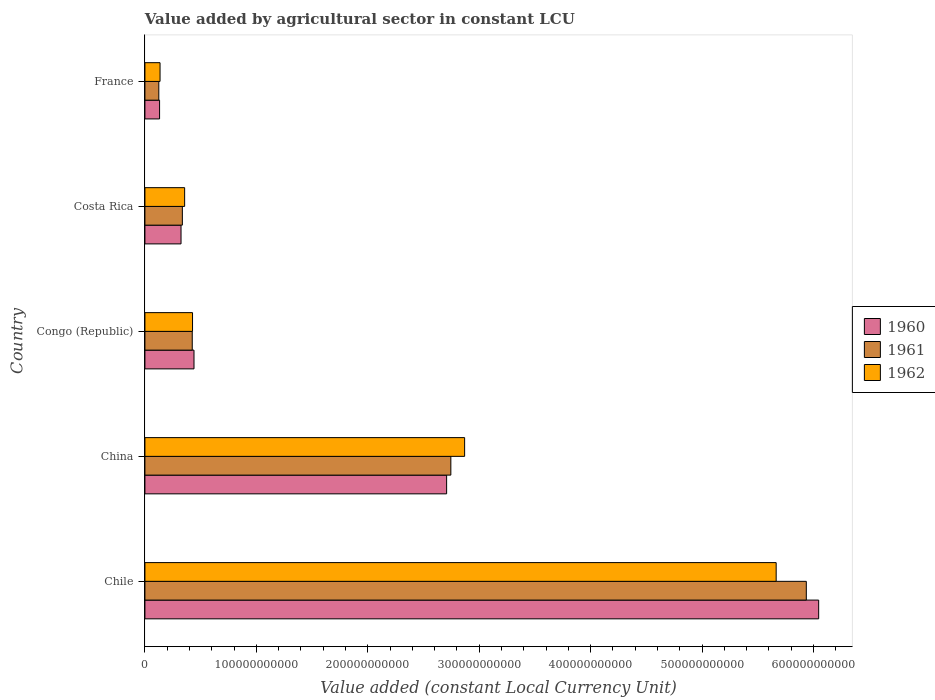How many different coloured bars are there?
Provide a succinct answer. 3. How many groups of bars are there?
Provide a short and direct response. 5. Are the number of bars on each tick of the Y-axis equal?
Provide a short and direct response. Yes. How many bars are there on the 3rd tick from the bottom?
Your response must be concise. 3. In how many cases, is the number of bars for a given country not equal to the number of legend labels?
Ensure brevity in your answer.  0. What is the value added by agricultural sector in 1960 in Chile?
Ensure brevity in your answer.  6.05e+11. Across all countries, what is the maximum value added by agricultural sector in 1960?
Keep it short and to the point. 6.05e+11. Across all countries, what is the minimum value added by agricultural sector in 1962?
Offer a very short reply. 1.36e+1. In which country was the value added by agricultural sector in 1962 maximum?
Your answer should be very brief. Chile. What is the total value added by agricultural sector in 1960 in the graph?
Your answer should be compact. 9.65e+11. What is the difference between the value added by agricultural sector in 1960 in China and that in Congo (Republic)?
Make the answer very short. 2.27e+11. What is the difference between the value added by agricultural sector in 1960 in China and the value added by agricultural sector in 1961 in France?
Keep it short and to the point. 2.58e+11. What is the average value added by agricultural sector in 1960 per country?
Your answer should be very brief. 1.93e+11. What is the difference between the value added by agricultural sector in 1962 and value added by agricultural sector in 1960 in Costa Rica?
Provide a short and direct response. 3.25e+09. In how many countries, is the value added by agricultural sector in 1960 greater than 240000000000 LCU?
Make the answer very short. 2. What is the ratio of the value added by agricultural sector in 1960 in China to that in Costa Rica?
Provide a short and direct response. 8.36. Is the value added by agricultural sector in 1961 in Chile less than that in Congo (Republic)?
Provide a succinct answer. No. Is the difference between the value added by agricultural sector in 1962 in Congo (Republic) and Costa Rica greater than the difference between the value added by agricultural sector in 1960 in Congo (Republic) and Costa Rica?
Provide a succinct answer. No. What is the difference between the highest and the second highest value added by agricultural sector in 1962?
Make the answer very short. 2.80e+11. What is the difference between the highest and the lowest value added by agricultural sector in 1962?
Offer a very short reply. 5.53e+11. What does the 2nd bar from the bottom in France represents?
Make the answer very short. 1961. What is the difference between two consecutive major ticks on the X-axis?
Offer a terse response. 1.00e+11. Are the values on the major ticks of X-axis written in scientific E-notation?
Your answer should be compact. No. Does the graph contain any zero values?
Give a very brief answer. No. Where does the legend appear in the graph?
Keep it short and to the point. Center right. How many legend labels are there?
Provide a succinct answer. 3. How are the legend labels stacked?
Provide a succinct answer. Vertical. What is the title of the graph?
Your answer should be very brief. Value added by agricultural sector in constant LCU. Does "1981" appear as one of the legend labels in the graph?
Your answer should be compact. No. What is the label or title of the X-axis?
Give a very brief answer. Value added (constant Local Currency Unit). What is the label or title of the Y-axis?
Give a very brief answer. Country. What is the Value added (constant Local Currency Unit) of 1960 in Chile?
Your answer should be compact. 6.05e+11. What is the Value added (constant Local Currency Unit) in 1961 in Chile?
Your answer should be very brief. 5.94e+11. What is the Value added (constant Local Currency Unit) in 1962 in Chile?
Your answer should be compact. 5.67e+11. What is the Value added (constant Local Currency Unit) of 1960 in China?
Provide a short and direct response. 2.71e+11. What is the Value added (constant Local Currency Unit) of 1961 in China?
Your answer should be compact. 2.75e+11. What is the Value added (constant Local Currency Unit) in 1962 in China?
Your answer should be very brief. 2.87e+11. What is the Value added (constant Local Currency Unit) in 1960 in Congo (Republic)?
Provide a short and direct response. 4.41e+1. What is the Value added (constant Local Currency Unit) in 1961 in Congo (Republic)?
Keep it short and to the point. 4.25e+1. What is the Value added (constant Local Currency Unit) of 1962 in Congo (Republic)?
Provide a succinct answer. 4.27e+1. What is the Value added (constant Local Currency Unit) of 1960 in Costa Rica?
Offer a terse response. 3.24e+1. What is the Value added (constant Local Currency Unit) in 1961 in Costa Rica?
Provide a short and direct response. 3.36e+1. What is the Value added (constant Local Currency Unit) in 1962 in Costa Rica?
Ensure brevity in your answer.  3.57e+1. What is the Value added (constant Local Currency Unit) in 1960 in France?
Make the answer very short. 1.32e+1. What is the Value added (constant Local Currency Unit) of 1961 in France?
Provide a succinct answer. 1.25e+1. What is the Value added (constant Local Currency Unit) of 1962 in France?
Provide a succinct answer. 1.36e+1. Across all countries, what is the maximum Value added (constant Local Currency Unit) of 1960?
Make the answer very short. 6.05e+11. Across all countries, what is the maximum Value added (constant Local Currency Unit) of 1961?
Your answer should be very brief. 5.94e+11. Across all countries, what is the maximum Value added (constant Local Currency Unit) of 1962?
Your response must be concise. 5.67e+11. Across all countries, what is the minimum Value added (constant Local Currency Unit) of 1960?
Your response must be concise. 1.32e+1. Across all countries, what is the minimum Value added (constant Local Currency Unit) in 1961?
Provide a succinct answer. 1.25e+1. Across all countries, what is the minimum Value added (constant Local Currency Unit) in 1962?
Your answer should be very brief. 1.36e+1. What is the total Value added (constant Local Currency Unit) of 1960 in the graph?
Provide a succinct answer. 9.65e+11. What is the total Value added (constant Local Currency Unit) in 1961 in the graph?
Ensure brevity in your answer.  9.57e+11. What is the total Value added (constant Local Currency Unit) of 1962 in the graph?
Provide a short and direct response. 9.45e+11. What is the difference between the Value added (constant Local Currency Unit) in 1960 in Chile and that in China?
Your answer should be compact. 3.34e+11. What is the difference between the Value added (constant Local Currency Unit) in 1961 in Chile and that in China?
Ensure brevity in your answer.  3.19e+11. What is the difference between the Value added (constant Local Currency Unit) of 1962 in Chile and that in China?
Your answer should be compact. 2.80e+11. What is the difference between the Value added (constant Local Currency Unit) in 1960 in Chile and that in Congo (Republic)?
Keep it short and to the point. 5.61e+11. What is the difference between the Value added (constant Local Currency Unit) of 1961 in Chile and that in Congo (Republic)?
Your response must be concise. 5.51e+11. What is the difference between the Value added (constant Local Currency Unit) in 1962 in Chile and that in Congo (Republic)?
Your answer should be very brief. 5.24e+11. What is the difference between the Value added (constant Local Currency Unit) of 1960 in Chile and that in Costa Rica?
Offer a terse response. 5.72e+11. What is the difference between the Value added (constant Local Currency Unit) of 1961 in Chile and that in Costa Rica?
Offer a very short reply. 5.60e+11. What is the difference between the Value added (constant Local Currency Unit) of 1962 in Chile and that in Costa Rica?
Ensure brevity in your answer.  5.31e+11. What is the difference between the Value added (constant Local Currency Unit) in 1960 in Chile and that in France?
Make the answer very short. 5.92e+11. What is the difference between the Value added (constant Local Currency Unit) of 1961 in Chile and that in France?
Your answer should be very brief. 5.81e+11. What is the difference between the Value added (constant Local Currency Unit) of 1962 in Chile and that in France?
Provide a short and direct response. 5.53e+11. What is the difference between the Value added (constant Local Currency Unit) of 1960 in China and that in Congo (Republic)?
Keep it short and to the point. 2.27e+11. What is the difference between the Value added (constant Local Currency Unit) in 1961 in China and that in Congo (Republic)?
Provide a succinct answer. 2.32e+11. What is the difference between the Value added (constant Local Currency Unit) of 1962 in China and that in Congo (Republic)?
Provide a short and direct response. 2.44e+11. What is the difference between the Value added (constant Local Currency Unit) of 1960 in China and that in Costa Rica?
Offer a terse response. 2.38e+11. What is the difference between the Value added (constant Local Currency Unit) of 1961 in China and that in Costa Rica?
Keep it short and to the point. 2.41e+11. What is the difference between the Value added (constant Local Currency Unit) of 1962 in China and that in Costa Rica?
Give a very brief answer. 2.51e+11. What is the difference between the Value added (constant Local Currency Unit) in 1960 in China and that in France?
Offer a terse response. 2.58e+11. What is the difference between the Value added (constant Local Currency Unit) in 1961 in China and that in France?
Make the answer very short. 2.62e+11. What is the difference between the Value added (constant Local Currency Unit) of 1962 in China and that in France?
Provide a succinct answer. 2.73e+11. What is the difference between the Value added (constant Local Currency Unit) of 1960 in Congo (Republic) and that in Costa Rica?
Ensure brevity in your answer.  1.17e+1. What is the difference between the Value added (constant Local Currency Unit) of 1961 in Congo (Republic) and that in Costa Rica?
Your response must be concise. 8.89e+09. What is the difference between the Value added (constant Local Currency Unit) of 1962 in Congo (Republic) and that in Costa Rica?
Offer a very short reply. 7.08e+09. What is the difference between the Value added (constant Local Currency Unit) in 1960 in Congo (Republic) and that in France?
Provide a short and direct response. 3.09e+1. What is the difference between the Value added (constant Local Currency Unit) in 1961 in Congo (Republic) and that in France?
Offer a terse response. 3.00e+1. What is the difference between the Value added (constant Local Currency Unit) of 1962 in Congo (Republic) and that in France?
Your answer should be compact. 2.92e+1. What is the difference between the Value added (constant Local Currency Unit) in 1960 in Costa Rica and that in France?
Provide a succinct answer. 1.92e+1. What is the difference between the Value added (constant Local Currency Unit) of 1961 in Costa Rica and that in France?
Offer a very short reply. 2.11e+1. What is the difference between the Value added (constant Local Currency Unit) in 1962 in Costa Rica and that in France?
Ensure brevity in your answer.  2.21e+1. What is the difference between the Value added (constant Local Currency Unit) in 1960 in Chile and the Value added (constant Local Currency Unit) in 1961 in China?
Your answer should be compact. 3.30e+11. What is the difference between the Value added (constant Local Currency Unit) of 1960 in Chile and the Value added (constant Local Currency Unit) of 1962 in China?
Offer a terse response. 3.18e+11. What is the difference between the Value added (constant Local Currency Unit) in 1961 in Chile and the Value added (constant Local Currency Unit) in 1962 in China?
Your response must be concise. 3.07e+11. What is the difference between the Value added (constant Local Currency Unit) of 1960 in Chile and the Value added (constant Local Currency Unit) of 1961 in Congo (Republic)?
Ensure brevity in your answer.  5.62e+11. What is the difference between the Value added (constant Local Currency Unit) in 1960 in Chile and the Value added (constant Local Currency Unit) in 1962 in Congo (Republic)?
Make the answer very short. 5.62e+11. What is the difference between the Value added (constant Local Currency Unit) in 1961 in Chile and the Value added (constant Local Currency Unit) in 1962 in Congo (Republic)?
Keep it short and to the point. 5.51e+11. What is the difference between the Value added (constant Local Currency Unit) in 1960 in Chile and the Value added (constant Local Currency Unit) in 1961 in Costa Rica?
Offer a terse response. 5.71e+11. What is the difference between the Value added (constant Local Currency Unit) of 1960 in Chile and the Value added (constant Local Currency Unit) of 1962 in Costa Rica?
Keep it short and to the point. 5.69e+11. What is the difference between the Value added (constant Local Currency Unit) in 1961 in Chile and the Value added (constant Local Currency Unit) in 1962 in Costa Rica?
Your answer should be compact. 5.58e+11. What is the difference between the Value added (constant Local Currency Unit) in 1960 in Chile and the Value added (constant Local Currency Unit) in 1961 in France?
Give a very brief answer. 5.92e+11. What is the difference between the Value added (constant Local Currency Unit) in 1960 in Chile and the Value added (constant Local Currency Unit) in 1962 in France?
Your answer should be very brief. 5.91e+11. What is the difference between the Value added (constant Local Currency Unit) in 1961 in Chile and the Value added (constant Local Currency Unit) in 1962 in France?
Make the answer very short. 5.80e+11. What is the difference between the Value added (constant Local Currency Unit) of 1960 in China and the Value added (constant Local Currency Unit) of 1961 in Congo (Republic)?
Your response must be concise. 2.28e+11. What is the difference between the Value added (constant Local Currency Unit) of 1960 in China and the Value added (constant Local Currency Unit) of 1962 in Congo (Republic)?
Ensure brevity in your answer.  2.28e+11. What is the difference between the Value added (constant Local Currency Unit) in 1961 in China and the Value added (constant Local Currency Unit) in 1962 in Congo (Republic)?
Give a very brief answer. 2.32e+11. What is the difference between the Value added (constant Local Currency Unit) of 1960 in China and the Value added (constant Local Currency Unit) of 1961 in Costa Rica?
Make the answer very short. 2.37e+11. What is the difference between the Value added (constant Local Currency Unit) in 1960 in China and the Value added (constant Local Currency Unit) in 1962 in Costa Rica?
Make the answer very short. 2.35e+11. What is the difference between the Value added (constant Local Currency Unit) of 1961 in China and the Value added (constant Local Currency Unit) of 1962 in Costa Rica?
Provide a short and direct response. 2.39e+11. What is the difference between the Value added (constant Local Currency Unit) in 1960 in China and the Value added (constant Local Currency Unit) in 1961 in France?
Offer a terse response. 2.58e+11. What is the difference between the Value added (constant Local Currency Unit) of 1960 in China and the Value added (constant Local Currency Unit) of 1962 in France?
Your answer should be very brief. 2.57e+11. What is the difference between the Value added (constant Local Currency Unit) of 1961 in China and the Value added (constant Local Currency Unit) of 1962 in France?
Provide a succinct answer. 2.61e+11. What is the difference between the Value added (constant Local Currency Unit) in 1960 in Congo (Republic) and the Value added (constant Local Currency Unit) in 1961 in Costa Rica?
Offer a terse response. 1.05e+1. What is the difference between the Value added (constant Local Currency Unit) in 1960 in Congo (Republic) and the Value added (constant Local Currency Unit) in 1962 in Costa Rica?
Your answer should be very brief. 8.40e+09. What is the difference between the Value added (constant Local Currency Unit) of 1961 in Congo (Republic) and the Value added (constant Local Currency Unit) of 1962 in Costa Rica?
Provide a succinct answer. 6.83e+09. What is the difference between the Value added (constant Local Currency Unit) of 1960 in Congo (Republic) and the Value added (constant Local Currency Unit) of 1961 in France?
Your answer should be very brief. 3.16e+1. What is the difference between the Value added (constant Local Currency Unit) in 1960 in Congo (Republic) and the Value added (constant Local Currency Unit) in 1962 in France?
Keep it short and to the point. 3.05e+1. What is the difference between the Value added (constant Local Currency Unit) of 1961 in Congo (Republic) and the Value added (constant Local Currency Unit) of 1962 in France?
Make the answer very short. 2.89e+1. What is the difference between the Value added (constant Local Currency Unit) of 1960 in Costa Rica and the Value added (constant Local Currency Unit) of 1961 in France?
Your answer should be very brief. 1.99e+1. What is the difference between the Value added (constant Local Currency Unit) of 1960 in Costa Rica and the Value added (constant Local Currency Unit) of 1962 in France?
Make the answer very short. 1.88e+1. What is the difference between the Value added (constant Local Currency Unit) in 1961 in Costa Rica and the Value added (constant Local Currency Unit) in 1962 in France?
Ensure brevity in your answer.  2.00e+1. What is the average Value added (constant Local Currency Unit) in 1960 per country?
Your answer should be very brief. 1.93e+11. What is the average Value added (constant Local Currency Unit) of 1961 per country?
Ensure brevity in your answer.  1.91e+11. What is the average Value added (constant Local Currency Unit) in 1962 per country?
Provide a succinct answer. 1.89e+11. What is the difference between the Value added (constant Local Currency Unit) in 1960 and Value added (constant Local Currency Unit) in 1961 in Chile?
Ensure brevity in your answer.  1.11e+1. What is the difference between the Value added (constant Local Currency Unit) of 1960 and Value added (constant Local Currency Unit) of 1962 in Chile?
Give a very brief answer. 3.82e+1. What is the difference between the Value added (constant Local Currency Unit) of 1961 and Value added (constant Local Currency Unit) of 1962 in Chile?
Give a very brief answer. 2.70e+1. What is the difference between the Value added (constant Local Currency Unit) of 1960 and Value added (constant Local Currency Unit) of 1961 in China?
Offer a very short reply. -3.79e+09. What is the difference between the Value added (constant Local Currency Unit) of 1960 and Value added (constant Local Currency Unit) of 1962 in China?
Keep it short and to the point. -1.61e+1. What is the difference between the Value added (constant Local Currency Unit) of 1961 and Value added (constant Local Currency Unit) of 1962 in China?
Your answer should be very brief. -1.24e+1. What is the difference between the Value added (constant Local Currency Unit) of 1960 and Value added (constant Local Currency Unit) of 1961 in Congo (Republic)?
Ensure brevity in your answer.  1.57e+09. What is the difference between the Value added (constant Local Currency Unit) in 1960 and Value added (constant Local Currency Unit) in 1962 in Congo (Republic)?
Provide a short and direct response. 1.32e+09. What is the difference between the Value added (constant Local Currency Unit) of 1961 and Value added (constant Local Currency Unit) of 1962 in Congo (Republic)?
Provide a short and direct response. -2.56e+08. What is the difference between the Value added (constant Local Currency Unit) in 1960 and Value added (constant Local Currency Unit) in 1961 in Costa Rica?
Keep it short and to the point. -1.19e+09. What is the difference between the Value added (constant Local Currency Unit) in 1960 and Value added (constant Local Currency Unit) in 1962 in Costa Rica?
Offer a terse response. -3.25e+09. What is the difference between the Value added (constant Local Currency Unit) in 1961 and Value added (constant Local Currency Unit) in 1962 in Costa Rica?
Your answer should be compact. -2.06e+09. What is the difference between the Value added (constant Local Currency Unit) of 1960 and Value added (constant Local Currency Unit) of 1961 in France?
Ensure brevity in your answer.  6.84e+08. What is the difference between the Value added (constant Local Currency Unit) in 1960 and Value added (constant Local Currency Unit) in 1962 in France?
Give a very brief answer. -4.23e+08. What is the difference between the Value added (constant Local Currency Unit) of 1961 and Value added (constant Local Currency Unit) of 1962 in France?
Ensure brevity in your answer.  -1.11e+09. What is the ratio of the Value added (constant Local Currency Unit) of 1960 in Chile to that in China?
Your response must be concise. 2.23. What is the ratio of the Value added (constant Local Currency Unit) of 1961 in Chile to that in China?
Keep it short and to the point. 2.16. What is the ratio of the Value added (constant Local Currency Unit) of 1962 in Chile to that in China?
Provide a succinct answer. 1.97. What is the ratio of the Value added (constant Local Currency Unit) of 1960 in Chile to that in Congo (Republic)?
Keep it short and to the point. 13.73. What is the ratio of the Value added (constant Local Currency Unit) in 1961 in Chile to that in Congo (Republic)?
Keep it short and to the point. 13.97. What is the ratio of the Value added (constant Local Currency Unit) of 1962 in Chile to that in Congo (Republic)?
Your answer should be compact. 13.26. What is the ratio of the Value added (constant Local Currency Unit) of 1960 in Chile to that in Costa Rica?
Offer a terse response. 18.66. What is the ratio of the Value added (constant Local Currency Unit) in 1961 in Chile to that in Costa Rica?
Offer a terse response. 17.67. What is the ratio of the Value added (constant Local Currency Unit) in 1962 in Chile to that in Costa Rica?
Provide a succinct answer. 15.89. What is the ratio of the Value added (constant Local Currency Unit) in 1960 in Chile to that in France?
Ensure brevity in your answer.  45.96. What is the ratio of the Value added (constant Local Currency Unit) in 1961 in Chile to that in France?
Provide a succinct answer. 47.59. What is the ratio of the Value added (constant Local Currency Unit) of 1962 in Chile to that in France?
Your answer should be compact. 41.72. What is the ratio of the Value added (constant Local Currency Unit) in 1960 in China to that in Congo (Republic)?
Offer a very short reply. 6.15. What is the ratio of the Value added (constant Local Currency Unit) of 1961 in China to that in Congo (Republic)?
Make the answer very short. 6.46. What is the ratio of the Value added (constant Local Currency Unit) of 1962 in China to that in Congo (Republic)?
Ensure brevity in your answer.  6.71. What is the ratio of the Value added (constant Local Currency Unit) of 1960 in China to that in Costa Rica?
Your response must be concise. 8.36. What is the ratio of the Value added (constant Local Currency Unit) of 1961 in China to that in Costa Rica?
Make the answer very short. 8.17. What is the ratio of the Value added (constant Local Currency Unit) in 1962 in China to that in Costa Rica?
Make the answer very short. 8.05. What is the ratio of the Value added (constant Local Currency Unit) in 1960 in China to that in France?
Make the answer very short. 20.58. What is the ratio of the Value added (constant Local Currency Unit) in 1961 in China to that in France?
Provide a succinct answer. 22.01. What is the ratio of the Value added (constant Local Currency Unit) of 1962 in China to that in France?
Offer a terse response. 21.13. What is the ratio of the Value added (constant Local Currency Unit) in 1960 in Congo (Republic) to that in Costa Rica?
Offer a very short reply. 1.36. What is the ratio of the Value added (constant Local Currency Unit) in 1961 in Congo (Republic) to that in Costa Rica?
Give a very brief answer. 1.26. What is the ratio of the Value added (constant Local Currency Unit) of 1962 in Congo (Republic) to that in Costa Rica?
Your response must be concise. 1.2. What is the ratio of the Value added (constant Local Currency Unit) of 1960 in Congo (Republic) to that in France?
Keep it short and to the point. 3.35. What is the ratio of the Value added (constant Local Currency Unit) in 1961 in Congo (Republic) to that in France?
Provide a succinct answer. 3.41. What is the ratio of the Value added (constant Local Currency Unit) of 1962 in Congo (Republic) to that in France?
Offer a terse response. 3.15. What is the ratio of the Value added (constant Local Currency Unit) of 1960 in Costa Rica to that in France?
Your answer should be very brief. 2.46. What is the ratio of the Value added (constant Local Currency Unit) of 1961 in Costa Rica to that in France?
Your answer should be very brief. 2.69. What is the ratio of the Value added (constant Local Currency Unit) of 1962 in Costa Rica to that in France?
Your answer should be very brief. 2.63. What is the difference between the highest and the second highest Value added (constant Local Currency Unit) in 1960?
Make the answer very short. 3.34e+11. What is the difference between the highest and the second highest Value added (constant Local Currency Unit) in 1961?
Your answer should be compact. 3.19e+11. What is the difference between the highest and the second highest Value added (constant Local Currency Unit) in 1962?
Offer a very short reply. 2.80e+11. What is the difference between the highest and the lowest Value added (constant Local Currency Unit) in 1960?
Keep it short and to the point. 5.92e+11. What is the difference between the highest and the lowest Value added (constant Local Currency Unit) in 1961?
Provide a succinct answer. 5.81e+11. What is the difference between the highest and the lowest Value added (constant Local Currency Unit) in 1962?
Offer a very short reply. 5.53e+11. 